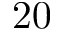Convert formula to latex. <formula><loc_0><loc_0><loc_500><loc_500>2 0</formula> 